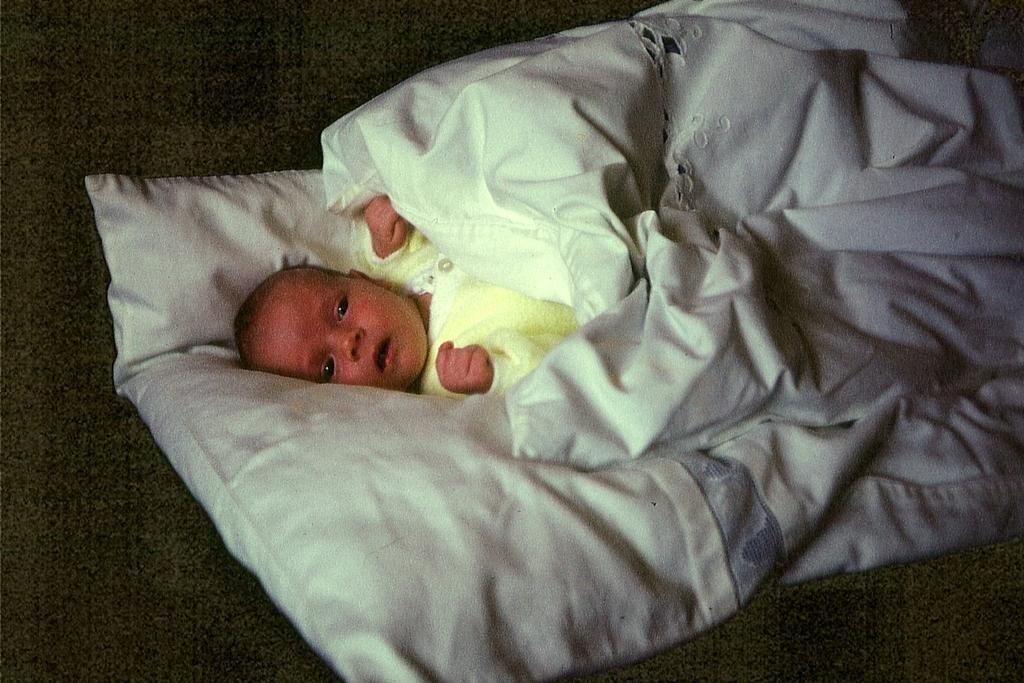Describe this image in one or two sentences. In the image we can see there is an infant lying on the bed and there is a blanket over the infant. 